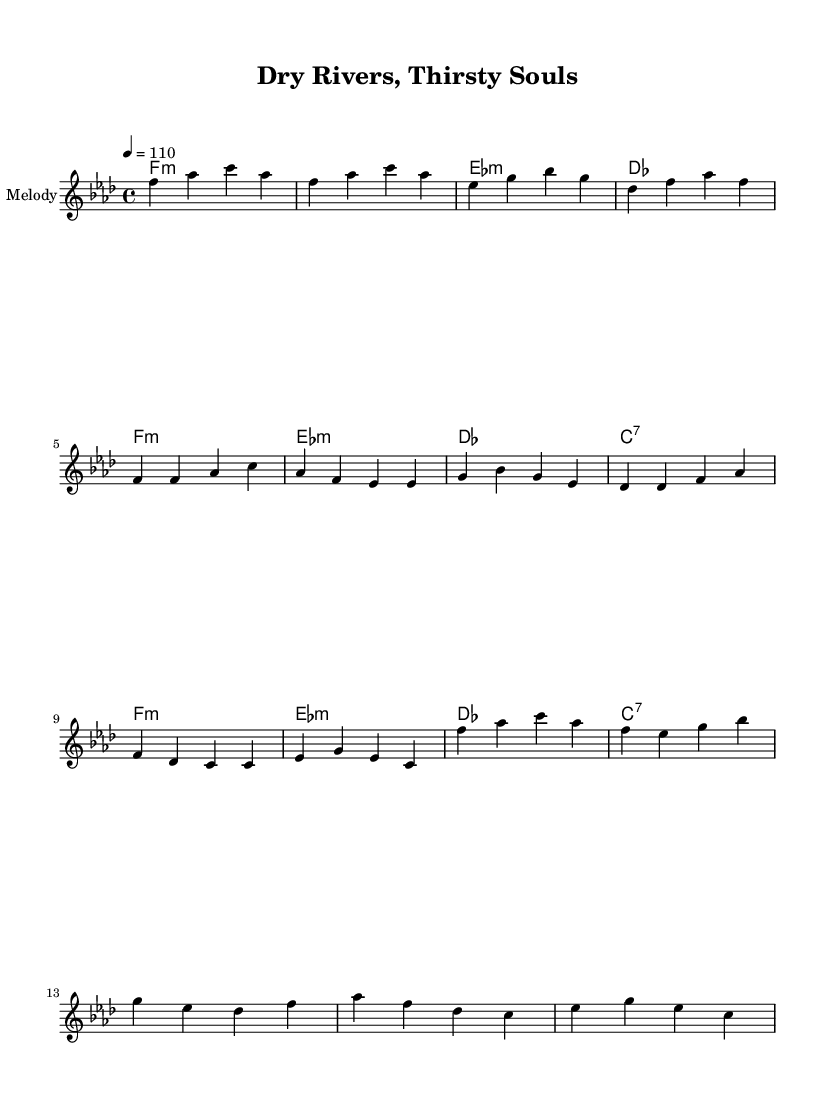What is the key signature of this music? The key signature is F minor, which has four flats (B♭, E♭, A♭, D♭). We can identify this by looking at the beginning of the staff where the key signature is notated.
Answer: F minor What is the time signature of this piece? The time signature is 4/4, indicating that there are four beats in each measure and the quarter note gets one beat. This can be found at the beginning of the score next to the key signature.
Answer: 4/4 What is the tempo marking for this composition? The tempo marking is 4 equals 110, which indicates a quarter note should be played at a speed of 110 beats per minute. The tempo can be seen towards the top of the score, clearly identifying the intended pace of the music.
Answer: 110 How many measures are there in the melody section? The melody section consists of 12 measures, which can be counted by identifying the vertical bar lines that separate the measures in the staff.
Answer: 12 What type of musical fusion does this piece represent? This piece represents Afro-funk fusion, a genre combining elements of African music rhythms with funk. The title "Dry Rivers, Thirsty Souls" also suggests themes relevant to struggles faced by communities experiencing drought. This can be inferred from the context of the title and the rhythmic style typical of such fusion.
Answer: Afro-funk fusion What is the primary theme reflected in the title of this piece? The title "Dry Rivers, Thirsty Souls" reflects the theme of water scarcity and its impact on communities. It evokes imagery of thirst and drought, linking the musical content to social issues and climate change. This thematic element can be recognized by analyzing the title and its implications.
Answer: Water scarcity 